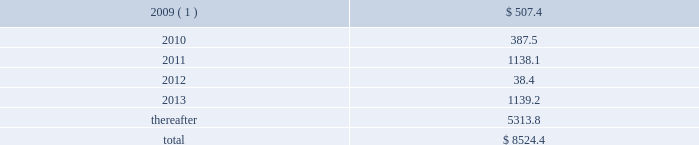The number of shares issued will be determined as the par value of the debentures divided by the average trading stock price over the preceding five-day period .
At december 31 , 2008 , the unamortized adjustment to fair value for these debentures was $ 28.7 million , which is being amortized through april 15 , 2011 , the first date that the holders can require us to redeem the debentures .
Tax-exempt financings as of december 31 , 2008 and 2007 , we had $ 1.3 billion and $ .7 billion of fixed and variable rate tax-exempt financings outstanding , respectively , with maturities ranging from 2010 to 2037 .
During 2008 , we issued $ 207.4 million of tax-exempt bonds .
In addition , we acquired $ 527.0 million of tax-exempt bonds and other tax-exempt financings as part of our acquisition of allied in december 2008 .
At december 31 , 2008 , the total of the unamortized adjustments to fair value for these financings was $ 52.9 million , which is being amortized to interest expense over the remaining terms of the debt .
Approximately two-thirds of our tax-exempt financings are remarketed weekly or daily , by a remarketing agent to effectively maintain a variable yield .
These variable rate tax-exempt financings are credit enhanced with letters of credit having terms in excess of one year issued by banks with credit ratings of aa or better .
The holders of the bonds can put them back to the remarketing agent at the end of each interest period .
To date , the remarketing agents have been able to remarket our variable rate unsecured tax-exempt bonds .
As of december 31 , 2008 , we had $ 281.9 million of restricted cash , of which $ 133.5 million was proceeds from the issuance of tax-exempt bonds and other tax-exempt financings and will be used to fund capital expenditures under the terms of the agreements .
Restricted cash also includes amounts held in trust as a financial guarantee of our performance .
Other debt other debt primarily includes capital lease liabilities of $ 139.5 million and $ 35.4 million as of december 31 , 2008 and 2007 , respectively , with maturities ranging from 2009 to 2042 .
Future maturities of debt aggregate maturities of notes payable , capital leases and other long-term debt as of december 31 , 2008 , excluding non-cash discounts , premiums , adjustments to fair market value of related to hedging transactions and adjustments to fair market value recorded in purchase accounting totaling $ 821.9 million , are as follows ( in millions ) : years ending december 31 , 2009 ( 1 ) .
$ 507.4 .
( 1 ) includes the receivables secured loan , which is a 364-day liquidity facility with a maturity date of may 29 , 2009 and has a balance of $ 400.0 million at december 31 , 2008 .
Although we intend to renew the liquidity facility prior to its maturity date , the outstanding balance is classified as a current liability because it has a contractual maturity of less than one year .
Republic services , inc .
And subsidiaries notes to consolidated financial statements %%transmsg*** transmitting job : p14076 pcn : 119000000 ***%%pcmsg|117 |00024|yes|no|02/28/2009 17:21|0|0|page is valid , no graphics -- color : d| .
\\nas of december 31 , 2008 , what was the percent of the proceeds form the issuance of the tax exempt and other tax exempt financing as part of the restricted cash\\n? 
Rationale: the percent is the difference divide by the total amount of the restricted cash
Computations: (133.5 / 281.9)
Answer: 0.47357. 